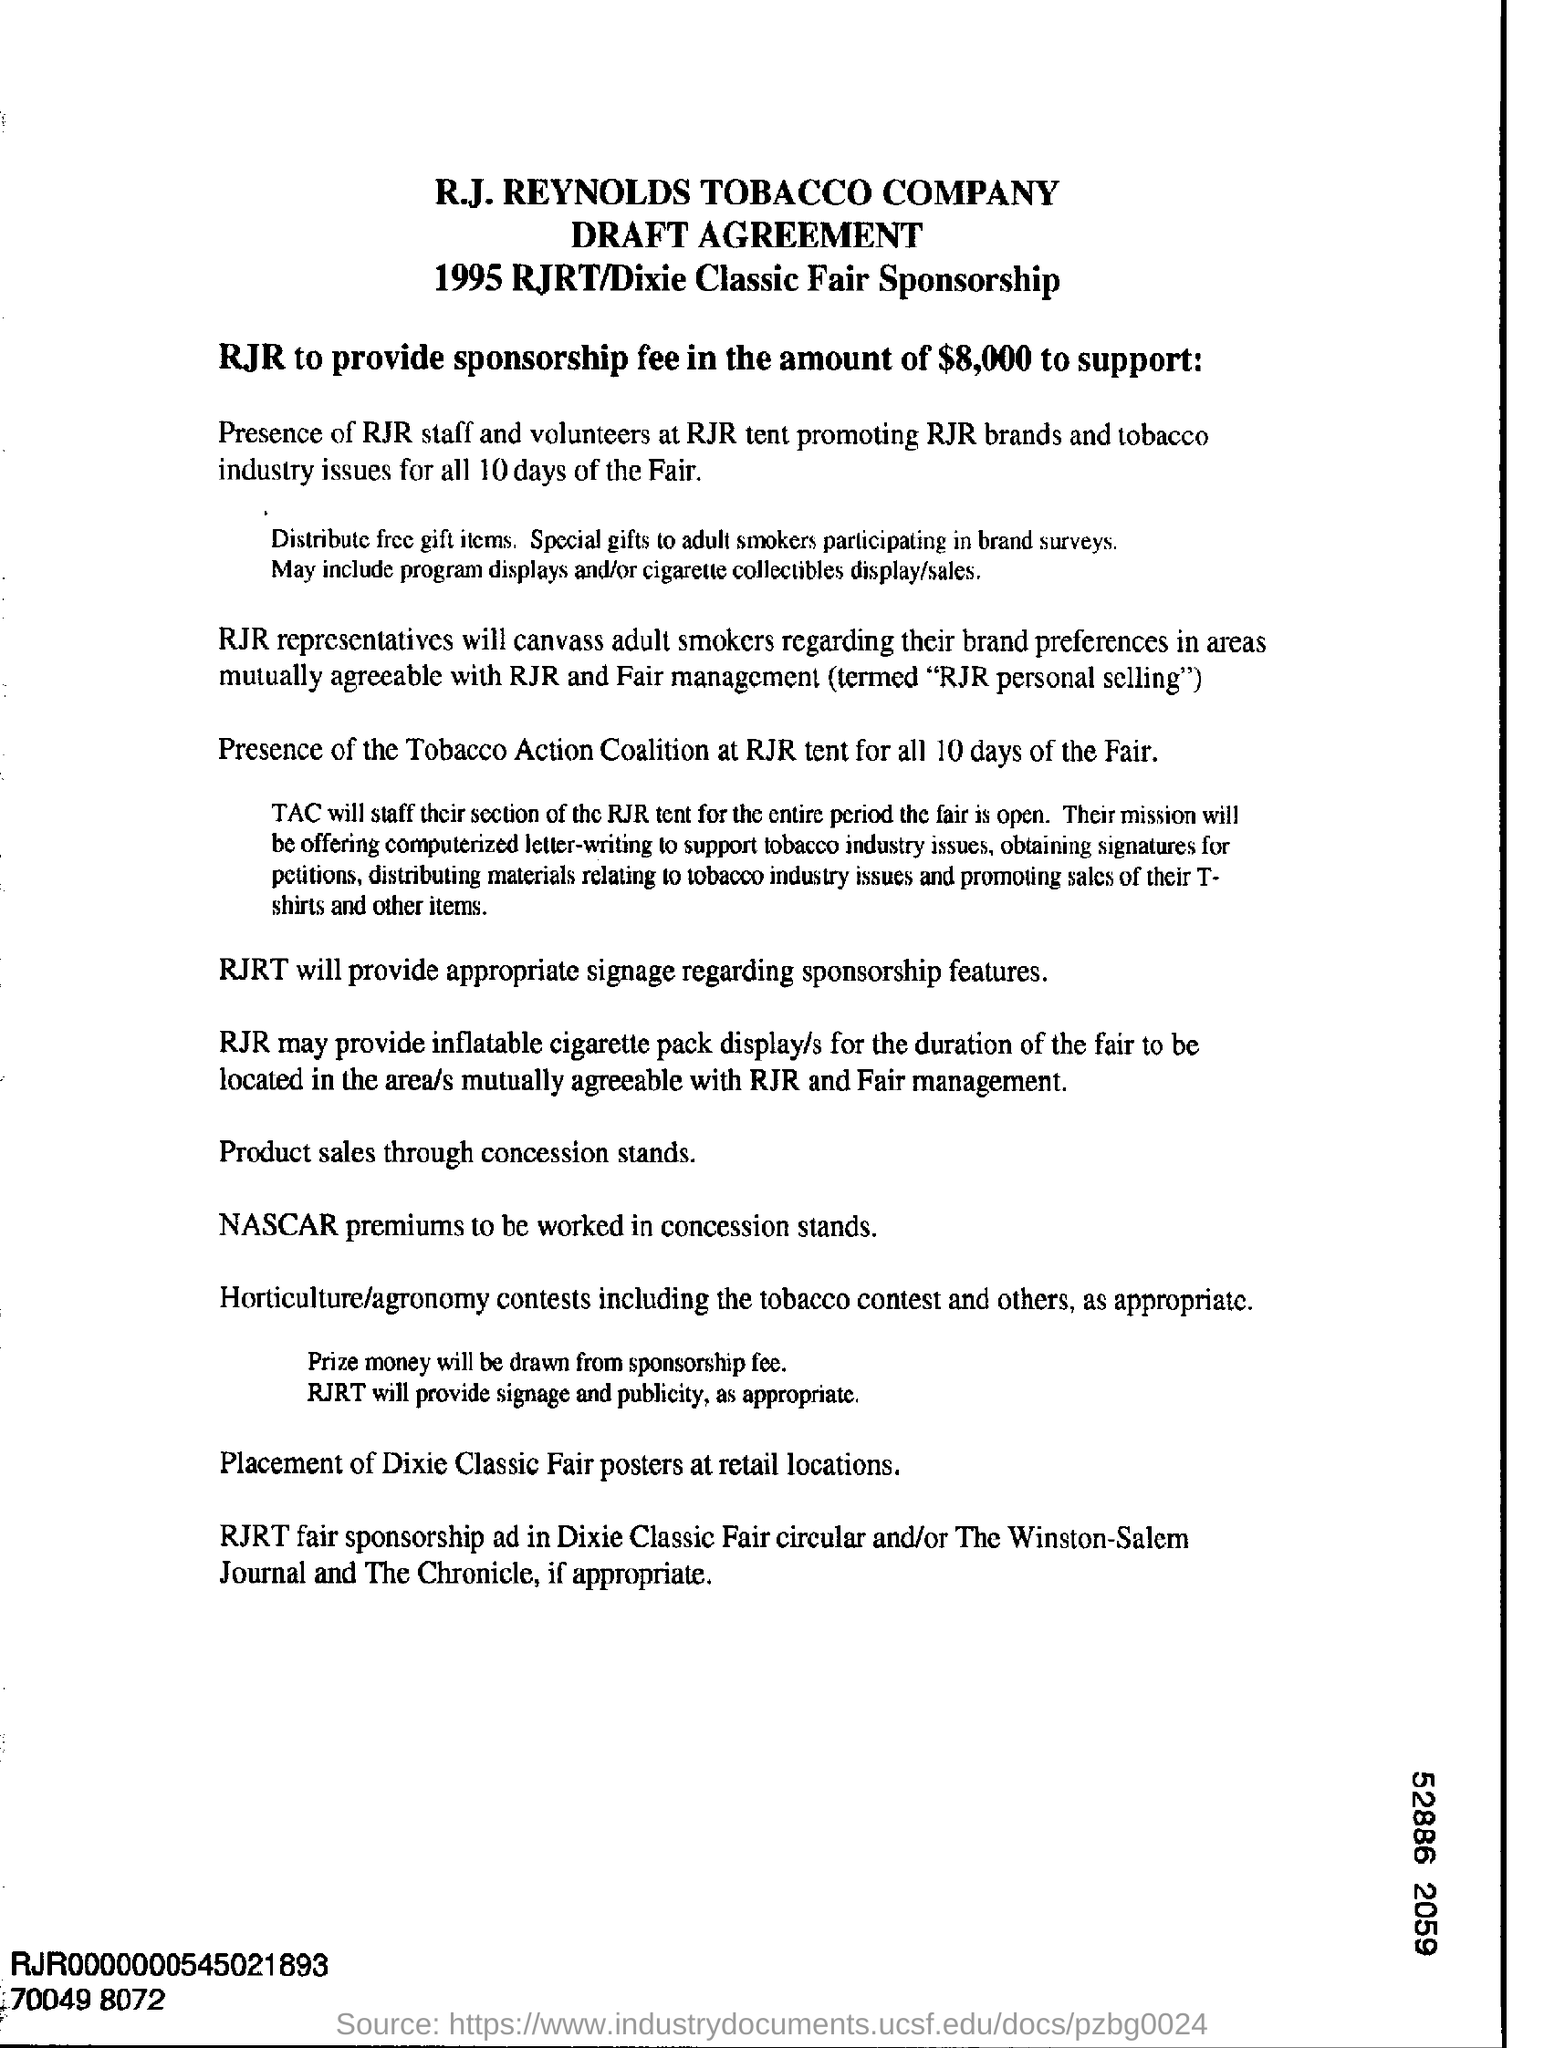Mention a couple of crucial points in this snapshot. The fair will last for 10 days. The Tobacco Action Coalition will be present at the RJR tent for all 10 days of the Fair. 